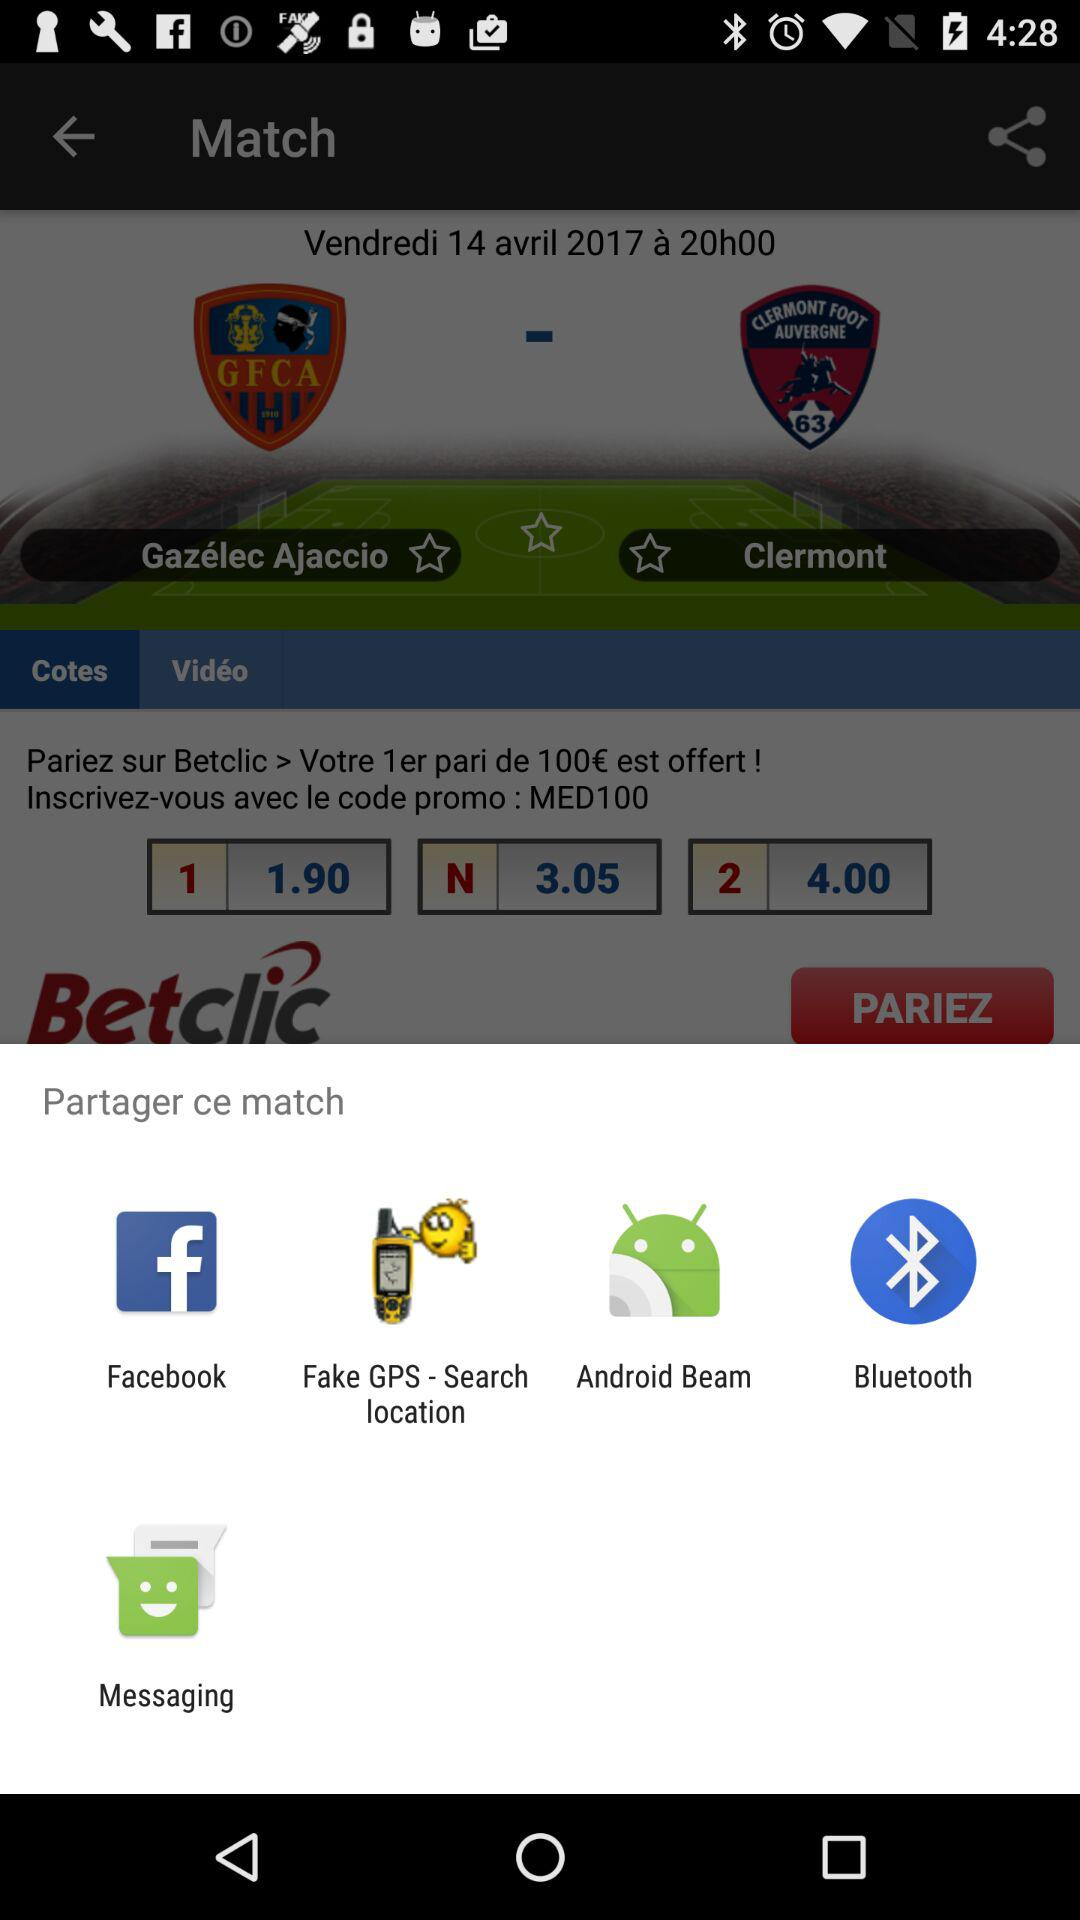What is the date and time?
When the provided information is insufficient, respond with <no answer>. <no answer> 